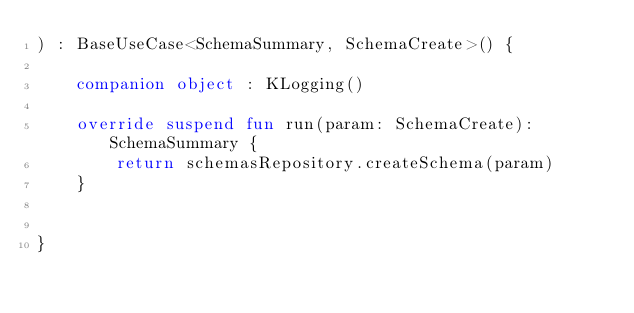<code> <loc_0><loc_0><loc_500><loc_500><_Kotlin_>) : BaseUseCase<SchemaSummary, SchemaCreate>() {

    companion object : KLogging()

    override suspend fun run(param: SchemaCreate): SchemaSummary {
        return schemasRepository.createSchema(param)
    }


}</code> 